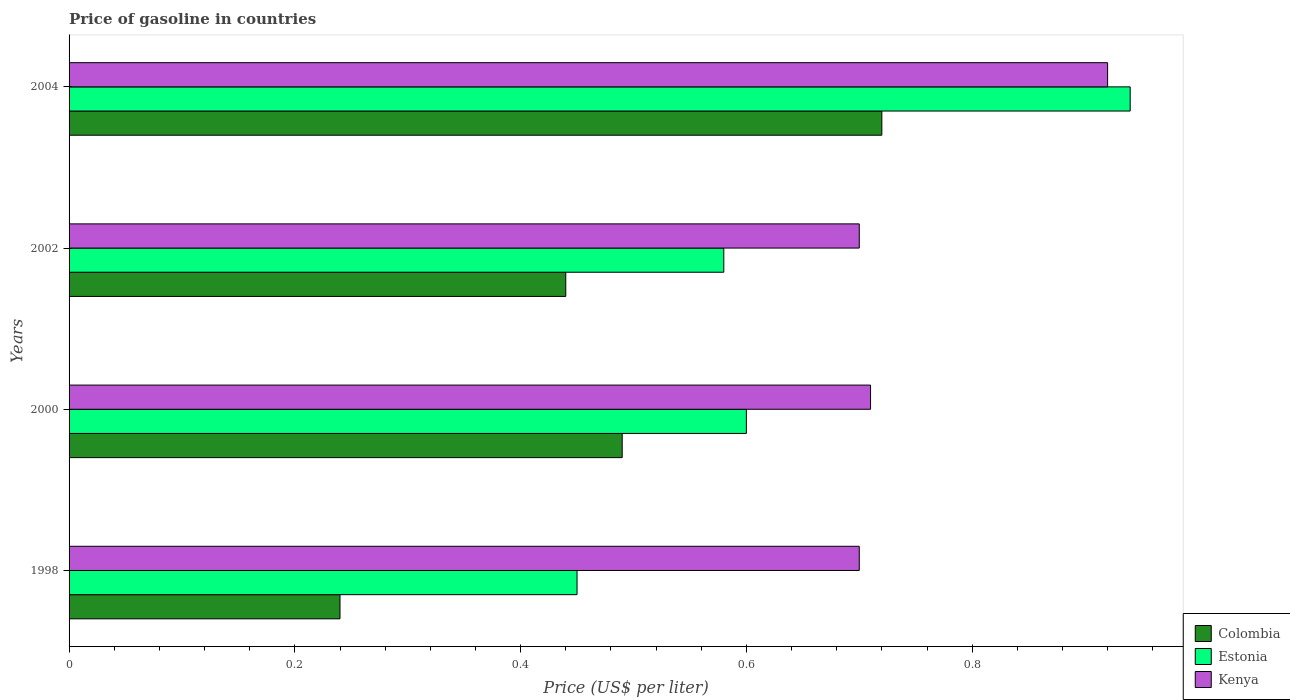How many different coloured bars are there?
Ensure brevity in your answer.  3. How many groups of bars are there?
Your answer should be compact. 4. How many bars are there on the 1st tick from the top?
Provide a succinct answer. 3. In how many cases, is the number of bars for a given year not equal to the number of legend labels?
Your response must be concise. 0. What is the price of gasoline in Kenya in 1998?
Offer a terse response. 0.7. Across all years, what is the maximum price of gasoline in Colombia?
Your answer should be compact. 0.72. Across all years, what is the minimum price of gasoline in Colombia?
Your answer should be compact. 0.24. In which year was the price of gasoline in Colombia maximum?
Give a very brief answer. 2004. In which year was the price of gasoline in Kenya minimum?
Offer a terse response. 1998. What is the total price of gasoline in Colombia in the graph?
Offer a terse response. 1.89. What is the difference between the price of gasoline in Kenya in 2000 and that in 2002?
Make the answer very short. 0.01. What is the average price of gasoline in Colombia per year?
Provide a succinct answer. 0.47. In the year 2002, what is the difference between the price of gasoline in Estonia and price of gasoline in Kenya?
Provide a short and direct response. -0.12. In how many years, is the price of gasoline in Colombia greater than 0.16 US$?
Your answer should be very brief. 4. What is the ratio of the price of gasoline in Colombia in 1998 to that in 2000?
Keep it short and to the point. 0.49. Is the price of gasoline in Estonia in 1998 less than that in 2000?
Provide a succinct answer. Yes. What is the difference between the highest and the second highest price of gasoline in Colombia?
Provide a short and direct response. 0.23. What is the difference between the highest and the lowest price of gasoline in Estonia?
Provide a succinct answer. 0.49. In how many years, is the price of gasoline in Estonia greater than the average price of gasoline in Estonia taken over all years?
Keep it short and to the point. 1. What does the 1st bar from the top in 2000 represents?
Offer a very short reply. Kenya. What does the 2nd bar from the bottom in 2002 represents?
Offer a very short reply. Estonia. Is it the case that in every year, the sum of the price of gasoline in Kenya and price of gasoline in Colombia is greater than the price of gasoline in Estonia?
Provide a succinct answer. Yes. Are all the bars in the graph horizontal?
Your answer should be very brief. Yes. What is the difference between two consecutive major ticks on the X-axis?
Ensure brevity in your answer.  0.2. Where does the legend appear in the graph?
Your response must be concise. Bottom right. How are the legend labels stacked?
Your answer should be compact. Vertical. What is the title of the graph?
Give a very brief answer. Price of gasoline in countries. What is the label or title of the X-axis?
Give a very brief answer. Price (US$ per liter). What is the Price (US$ per liter) in Colombia in 1998?
Ensure brevity in your answer.  0.24. What is the Price (US$ per liter) of Estonia in 1998?
Offer a terse response. 0.45. What is the Price (US$ per liter) in Kenya in 1998?
Give a very brief answer. 0.7. What is the Price (US$ per liter) of Colombia in 2000?
Your answer should be very brief. 0.49. What is the Price (US$ per liter) of Kenya in 2000?
Offer a terse response. 0.71. What is the Price (US$ per liter) in Colombia in 2002?
Offer a terse response. 0.44. What is the Price (US$ per liter) in Estonia in 2002?
Your response must be concise. 0.58. What is the Price (US$ per liter) of Colombia in 2004?
Provide a succinct answer. 0.72. What is the Price (US$ per liter) in Estonia in 2004?
Your response must be concise. 0.94. Across all years, what is the maximum Price (US$ per liter) of Colombia?
Provide a succinct answer. 0.72. Across all years, what is the maximum Price (US$ per liter) of Kenya?
Offer a very short reply. 0.92. Across all years, what is the minimum Price (US$ per liter) of Colombia?
Offer a very short reply. 0.24. Across all years, what is the minimum Price (US$ per liter) of Estonia?
Offer a very short reply. 0.45. Across all years, what is the minimum Price (US$ per liter) of Kenya?
Offer a very short reply. 0.7. What is the total Price (US$ per liter) of Colombia in the graph?
Ensure brevity in your answer.  1.89. What is the total Price (US$ per liter) in Estonia in the graph?
Make the answer very short. 2.57. What is the total Price (US$ per liter) of Kenya in the graph?
Offer a terse response. 3.03. What is the difference between the Price (US$ per liter) in Colombia in 1998 and that in 2000?
Offer a very short reply. -0.25. What is the difference between the Price (US$ per liter) of Kenya in 1998 and that in 2000?
Your answer should be very brief. -0.01. What is the difference between the Price (US$ per liter) in Estonia in 1998 and that in 2002?
Give a very brief answer. -0.13. What is the difference between the Price (US$ per liter) in Colombia in 1998 and that in 2004?
Ensure brevity in your answer.  -0.48. What is the difference between the Price (US$ per liter) of Estonia in 1998 and that in 2004?
Give a very brief answer. -0.49. What is the difference between the Price (US$ per liter) of Kenya in 1998 and that in 2004?
Your answer should be very brief. -0.22. What is the difference between the Price (US$ per liter) of Colombia in 2000 and that in 2002?
Your response must be concise. 0.05. What is the difference between the Price (US$ per liter) of Kenya in 2000 and that in 2002?
Make the answer very short. 0.01. What is the difference between the Price (US$ per liter) of Colombia in 2000 and that in 2004?
Offer a terse response. -0.23. What is the difference between the Price (US$ per liter) in Estonia in 2000 and that in 2004?
Ensure brevity in your answer.  -0.34. What is the difference between the Price (US$ per liter) of Kenya in 2000 and that in 2004?
Your response must be concise. -0.21. What is the difference between the Price (US$ per liter) of Colombia in 2002 and that in 2004?
Provide a succinct answer. -0.28. What is the difference between the Price (US$ per liter) in Estonia in 2002 and that in 2004?
Make the answer very short. -0.36. What is the difference between the Price (US$ per liter) of Kenya in 2002 and that in 2004?
Your response must be concise. -0.22. What is the difference between the Price (US$ per liter) of Colombia in 1998 and the Price (US$ per liter) of Estonia in 2000?
Give a very brief answer. -0.36. What is the difference between the Price (US$ per liter) in Colombia in 1998 and the Price (US$ per liter) in Kenya in 2000?
Offer a very short reply. -0.47. What is the difference between the Price (US$ per liter) of Estonia in 1998 and the Price (US$ per liter) of Kenya in 2000?
Offer a very short reply. -0.26. What is the difference between the Price (US$ per liter) in Colombia in 1998 and the Price (US$ per liter) in Estonia in 2002?
Provide a short and direct response. -0.34. What is the difference between the Price (US$ per liter) in Colombia in 1998 and the Price (US$ per liter) in Kenya in 2002?
Provide a short and direct response. -0.46. What is the difference between the Price (US$ per liter) in Estonia in 1998 and the Price (US$ per liter) in Kenya in 2002?
Your answer should be very brief. -0.25. What is the difference between the Price (US$ per liter) in Colombia in 1998 and the Price (US$ per liter) in Estonia in 2004?
Provide a succinct answer. -0.7. What is the difference between the Price (US$ per liter) of Colombia in 1998 and the Price (US$ per liter) of Kenya in 2004?
Your response must be concise. -0.68. What is the difference between the Price (US$ per liter) of Estonia in 1998 and the Price (US$ per liter) of Kenya in 2004?
Keep it short and to the point. -0.47. What is the difference between the Price (US$ per liter) of Colombia in 2000 and the Price (US$ per liter) of Estonia in 2002?
Give a very brief answer. -0.09. What is the difference between the Price (US$ per liter) of Colombia in 2000 and the Price (US$ per liter) of Kenya in 2002?
Your answer should be compact. -0.21. What is the difference between the Price (US$ per liter) of Colombia in 2000 and the Price (US$ per liter) of Estonia in 2004?
Your answer should be very brief. -0.45. What is the difference between the Price (US$ per liter) of Colombia in 2000 and the Price (US$ per liter) of Kenya in 2004?
Keep it short and to the point. -0.43. What is the difference between the Price (US$ per liter) in Estonia in 2000 and the Price (US$ per liter) in Kenya in 2004?
Give a very brief answer. -0.32. What is the difference between the Price (US$ per liter) in Colombia in 2002 and the Price (US$ per liter) in Kenya in 2004?
Keep it short and to the point. -0.48. What is the difference between the Price (US$ per liter) in Estonia in 2002 and the Price (US$ per liter) in Kenya in 2004?
Your answer should be very brief. -0.34. What is the average Price (US$ per liter) of Colombia per year?
Your response must be concise. 0.47. What is the average Price (US$ per liter) of Estonia per year?
Your response must be concise. 0.64. What is the average Price (US$ per liter) of Kenya per year?
Provide a short and direct response. 0.76. In the year 1998, what is the difference between the Price (US$ per liter) of Colombia and Price (US$ per liter) of Estonia?
Keep it short and to the point. -0.21. In the year 1998, what is the difference between the Price (US$ per liter) in Colombia and Price (US$ per liter) in Kenya?
Keep it short and to the point. -0.46. In the year 1998, what is the difference between the Price (US$ per liter) of Estonia and Price (US$ per liter) of Kenya?
Offer a very short reply. -0.25. In the year 2000, what is the difference between the Price (US$ per liter) of Colombia and Price (US$ per liter) of Estonia?
Your response must be concise. -0.11. In the year 2000, what is the difference between the Price (US$ per liter) of Colombia and Price (US$ per liter) of Kenya?
Your answer should be compact. -0.22. In the year 2000, what is the difference between the Price (US$ per liter) in Estonia and Price (US$ per liter) in Kenya?
Offer a terse response. -0.11. In the year 2002, what is the difference between the Price (US$ per liter) of Colombia and Price (US$ per liter) of Estonia?
Offer a very short reply. -0.14. In the year 2002, what is the difference between the Price (US$ per liter) in Colombia and Price (US$ per liter) in Kenya?
Provide a succinct answer. -0.26. In the year 2002, what is the difference between the Price (US$ per liter) of Estonia and Price (US$ per liter) of Kenya?
Offer a terse response. -0.12. In the year 2004, what is the difference between the Price (US$ per liter) in Colombia and Price (US$ per liter) in Estonia?
Ensure brevity in your answer.  -0.22. What is the ratio of the Price (US$ per liter) of Colombia in 1998 to that in 2000?
Your answer should be compact. 0.49. What is the ratio of the Price (US$ per liter) in Kenya in 1998 to that in 2000?
Your answer should be very brief. 0.99. What is the ratio of the Price (US$ per liter) of Colombia in 1998 to that in 2002?
Offer a terse response. 0.55. What is the ratio of the Price (US$ per liter) of Estonia in 1998 to that in 2002?
Make the answer very short. 0.78. What is the ratio of the Price (US$ per liter) of Estonia in 1998 to that in 2004?
Ensure brevity in your answer.  0.48. What is the ratio of the Price (US$ per liter) in Kenya in 1998 to that in 2004?
Your answer should be very brief. 0.76. What is the ratio of the Price (US$ per liter) in Colombia in 2000 to that in 2002?
Your answer should be very brief. 1.11. What is the ratio of the Price (US$ per liter) in Estonia in 2000 to that in 2002?
Your answer should be compact. 1.03. What is the ratio of the Price (US$ per liter) in Kenya in 2000 to that in 2002?
Provide a succinct answer. 1.01. What is the ratio of the Price (US$ per liter) in Colombia in 2000 to that in 2004?
Offer a very short reply. 0.68. What is the ratio of the Price (US$ per liter) in Estonia in 2000 to that in 2004?
Your answer should be compact. 0.64. What is the ratio of the Price (US$ per liter) of Kenya in 2000 to that in 2004?
Make the answer very short. 0.77. What is the ratio of the Price (US$ per liter) in Colombia in 2002 to that in 2004?
Keep it short and to the point. 0.61. What is the ratio of the Price (US$ per liter) of Estonia in 2002 to that in 2004?
Ensure brevity in your answer.  0.62. What is the ratio of the Price (US$ per liter) of Kenya in 2002 to that in 2004?
Your answer should be very brief. 0.76. What is the difference between the highest and the second highest Price (US$ per liter) in Colombia?
Offer a very short reply. 0.23. What is the difference between the highest and the second highest Price (US$ per liter) in Estonia?
Your answer should be compact. 0.34. What is the difference between the highest and the second highest Price (US$ per liter) of Kenya?
Offer a very short reply. 0.21. What is the difference between the highest and the lowest Price (US$ per liter) of Colombia?
Offer a very short reply. 0.48. What is the difference between the highest and the lowest Price (US$ per liter) of Estonia?
Ensure brevity in your answer.  0.49. What is the difference between the highest and the lowest Price (US$ per liter) of Kenya?
Provide a succinct answer. 0.22. 